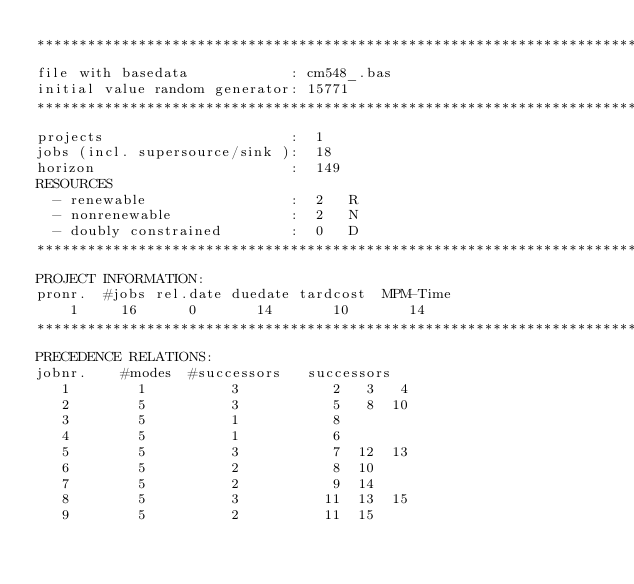<code> <loc_0><loc_0><loc_500><loc_500><_ObjectiveC_>************************************************************************
file with basedata            : cm548_.bas
initial value random generator: 15771
************************************************************************
projects                      :  1
jobs (incl. supersource/sink ):  18
horizon                       :  149
RESOURCES
  - renewable                 :  2   R
  - nonrenewable              :  2   N
  - doubly constrained        :  0   D
************************************************************************
PROJECT INFORMATION:
pronr.  #jobs rel.date duedate tardcost  MPM-Time
    1     16      0       14       10       14
************************************************************************
PRECEDENCE RELATIONS:
jobnr.    #modes  #successors   successors
   1        1          3           2   3   4
   2        5          3           5   8  10
   3        5          1           8
   4        5          1           6
   5        5          3           7  12  13
   6        5          2           8  10
   7        5          2           9  14
   8        5          3          11  13  15
   9        5          2          11  15</code> 